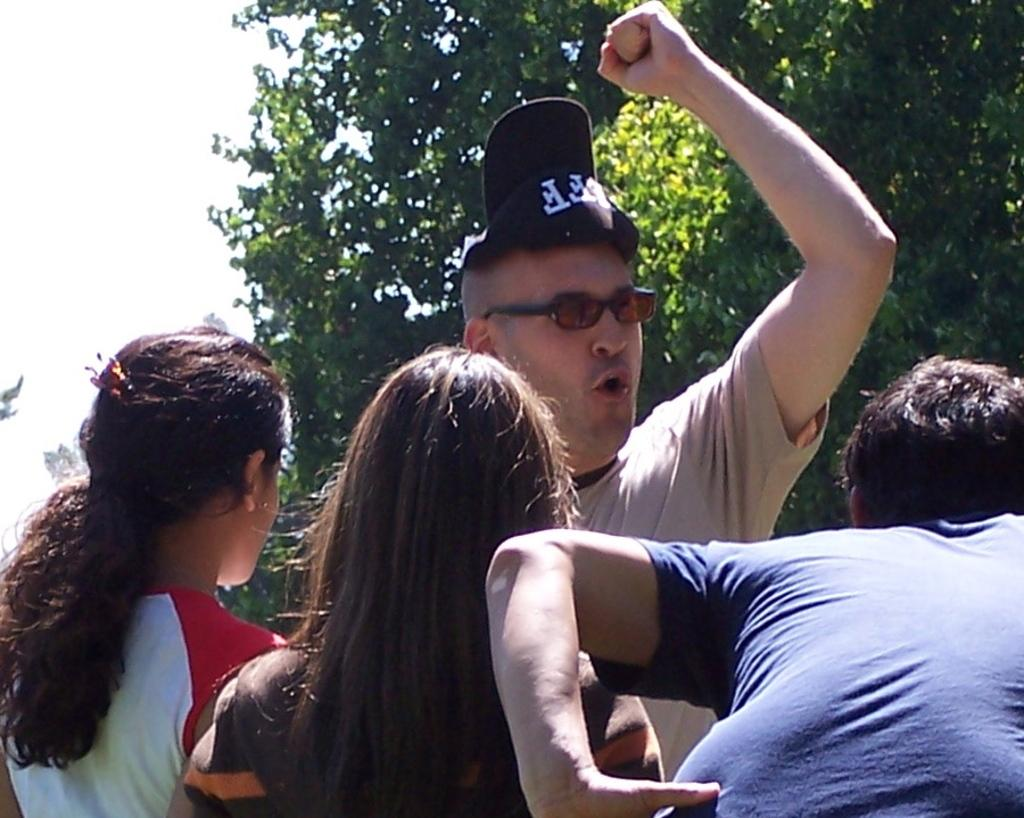What is the main subject of the image? The main subject of the image is a group of persons standing in the center. What can be seen in the background of the image? There is a tree and the sky visible in the background of the image. What type of yam is being used as a prop by the persons in the image? There is no yam present in the image; it features a group of persons standing in the center with a tree and the sky visible in the background. 